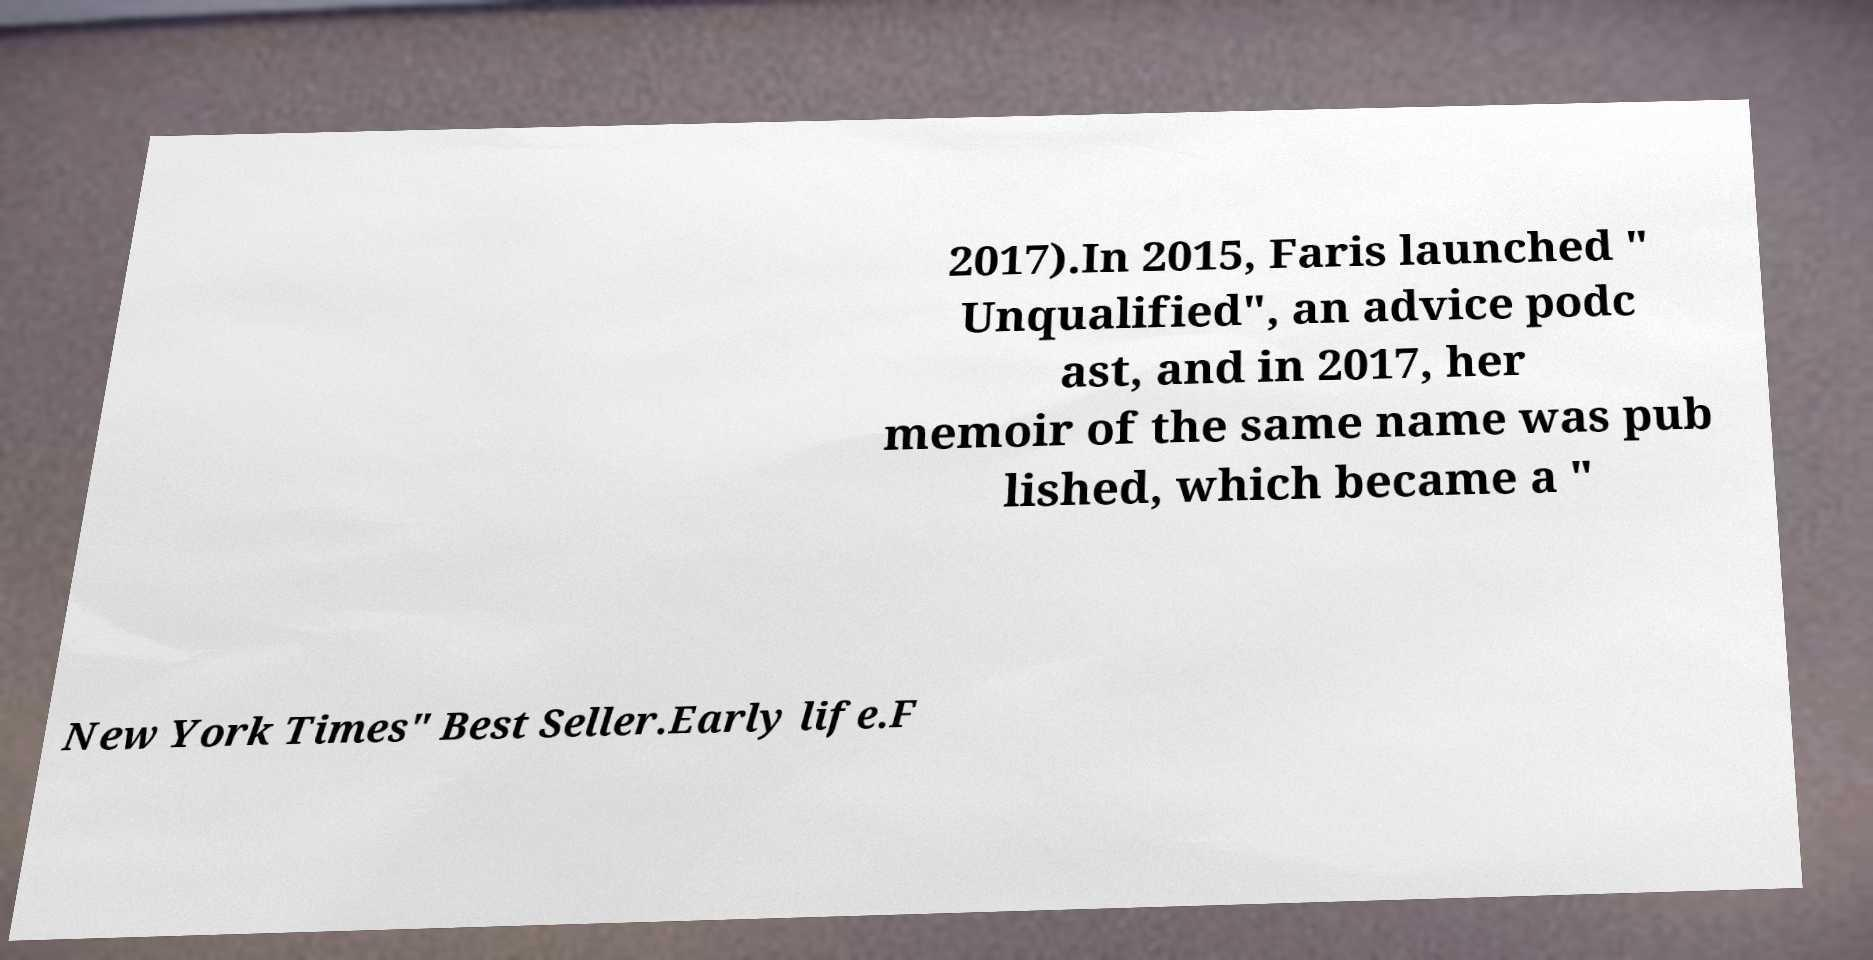I need the written content from this picture converted into text. Can you do that? 2017).In 2015, Faris launched " Unqualified", an advice podc ast, and in 2017, her memoir of the same name was pub lished, which became a " New York Times" Best Seller.Early life.F 